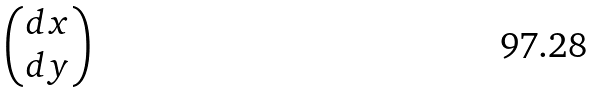<formula> <loc_0><loc_0><loc_500><loc_500>\begin{pmatrix} d x \\ d y \end{pmatrix}</formula> 